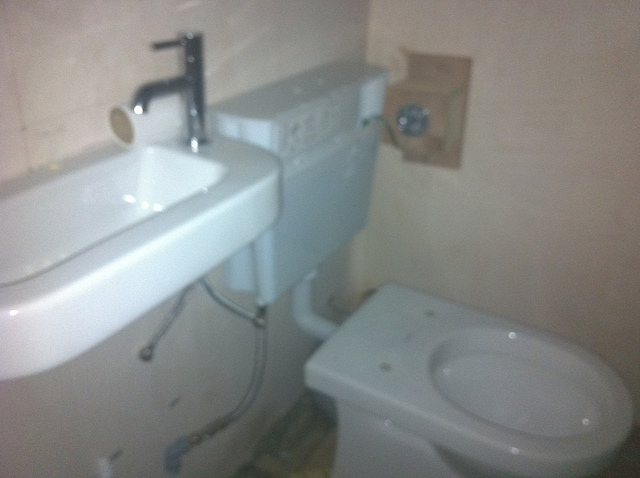Is there a toilet seat on the toilet? No, it seems that the toilet is missing a seat, which is an unusual condition for a functional bathroom. 